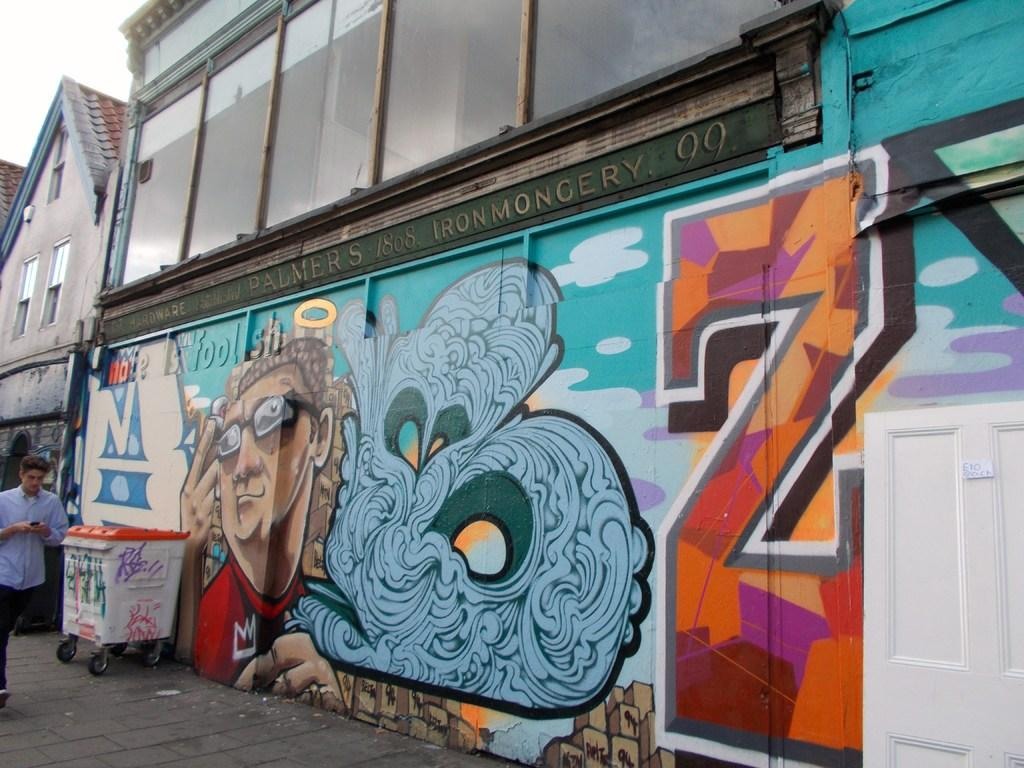What is on the building wall in the image? There is an art piece on the building wall in the image. Can you describe the person in the image? The person in the image is wearing clothes and is walking beside the wall. What is located in the bottom left of the image? There is a trash bin in the bottom left of the image. How many cherries are on the person's head in the image? There are no cherries present on the person's head in the image. What type of arch can be seen in the image? There is no arch present in the image. 